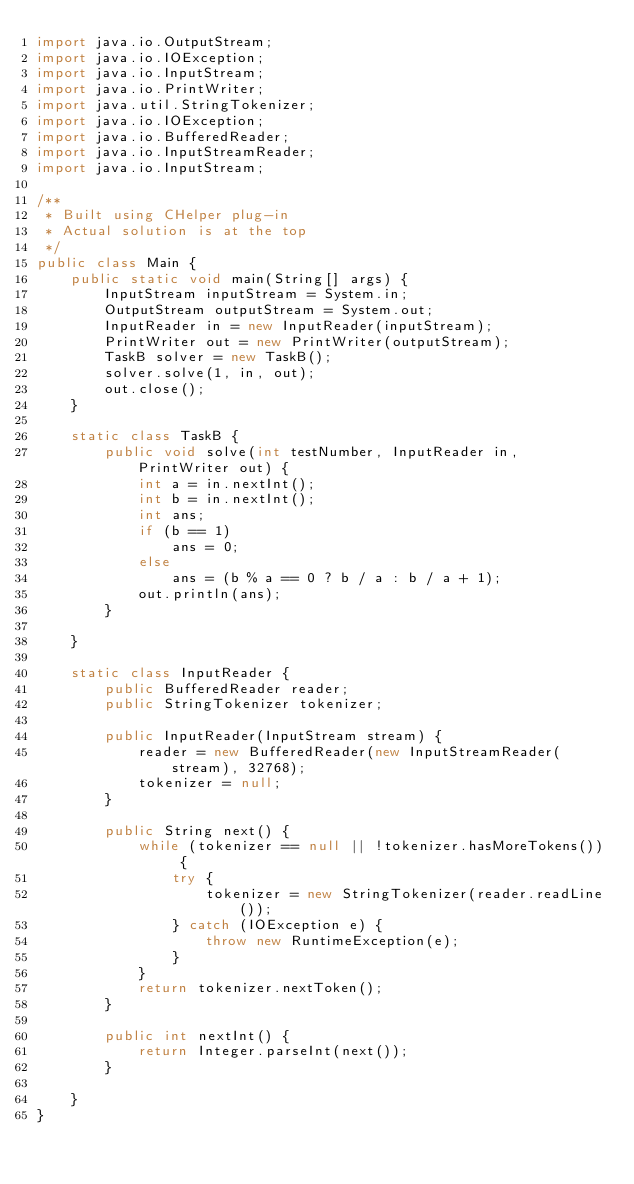Convert code to text. <code><loc_0><loc_0><loc_500><loc_500><_Java_>import java.io.OutputStream;
import java.io.IOException;
import java.io.InputStream;
import java.io.PrintWriter;
import java.util.StringTokenizer;
import java.io.IOException;
import java.io.BufferedReader;
import java.io.InputStreamReader;
import java.io.InputStream;

/**
 * Built using CHelper plug-in
 * Actual solution is at the top
 */
public class Main {
    public static void main(String[] args) {
        InputStream inputStream = System.in;
        OutputStream outputStream = System.out;
        InputReader in = new InputReader(inputStream);
        PrintWriter out = new PrintWriter(outputStream);
        TaskB solver = new TaskB();
        solver.solve(1, in, out);
        out.close();
    }

    static class TaskB {
        public void solve(int testNumber, InputReader in, PrintWriter out) {
            int a = in.nextInt();
            int b = in.nextInt();
            int ans;
            if (b == 1)
                ans = 0;
            else
                ans = (b % a == 0 ? b / a : b / a + 1);
            out.println(ans);
        }

    }

    static class InputReader {
        public BufferedReader reader;
        public StringTokenizer tokenizer;

        public InputReader(InputStream stream) {
            reader = new BufferedReader(new InputStreamReader(stream), 32768);
            tokenizer = null;
        }

        public String next() {
            while (tokenizer == null || !tokenizer.hasMoreTokens()) {
                try {
                    tokenizer = new StringTokenizer(reader.readLine());
                } catch (IOException e) {
                    throw new RuntimeException(e);
                }
            }
            return tokenizer.nextToken();
        }

        public int nextInt() {
            return Integer.parseInt(next());
        }

    }
}

</code> 